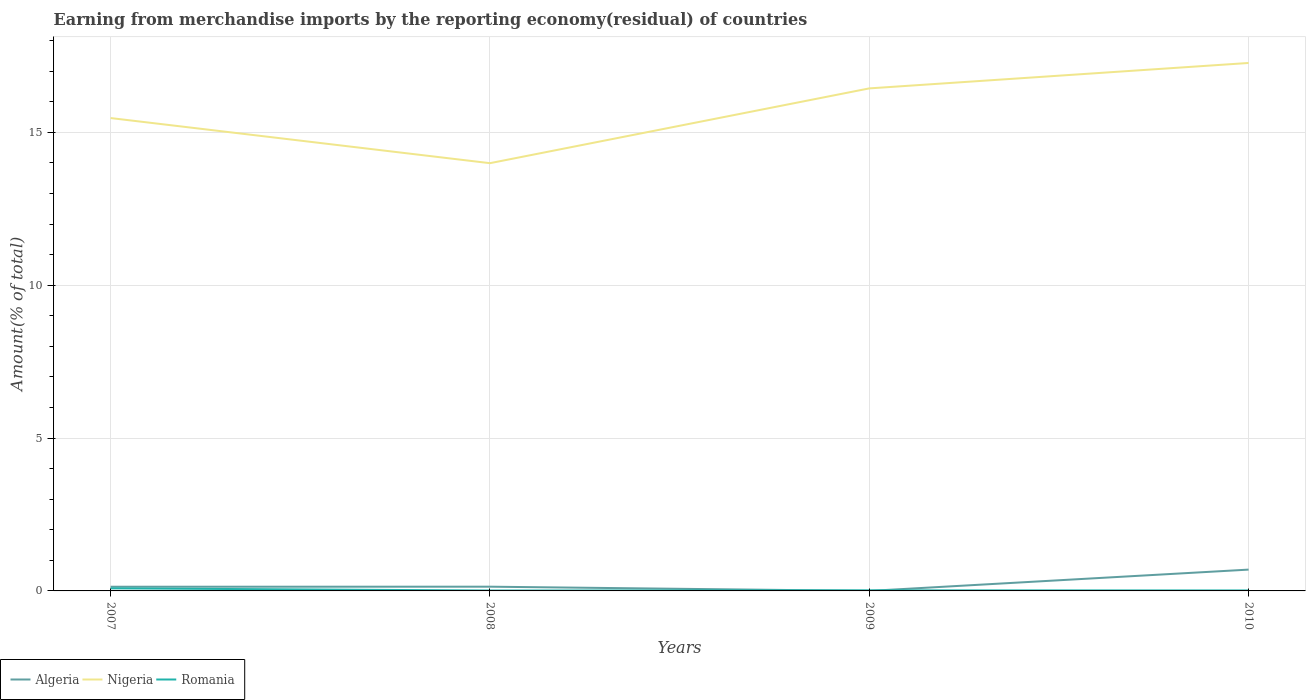How many different coloured lines are there?
Your answer should be very brief. 3. Does the line corresponding to Romania intersect with the line corresponding to Nigeria?
Provide a succinct answer. No. Is the number of lines equal to the number of legend labels?
Keep it short and to the point. Yes. Across all years, what is the maximum percentage of amount earned from merchandise imports in Nigeria?
Keep it short and to the point. 13.99. In which year was the percentage of amount earned from merchandise imports in Nigeria maximum?
Offer a very short reply. 2008. What is the total percentage of amount earned from merchandise imports in Algeria in the graph?
Your response must be concise. -0.7. What is the difference between the highest and the second highest percentage of amount earned from merchandise imports in Nigeria?
Your answer should be compact. 3.28. Does the graph contain any zero values?
Provide a succinct answer. No. Does the graph contain grids?
Keep it short and to the point. Yes. How many legend labels are there?
Give a very brief answer. 3. What is the title of the graph?
Make the answer very short. Earning from merchandise imports by the reporting economy(residual) of countries. What is the label or title of the Y-axis?
Ensure brevity in your answer.  Amount(% of total). What is the Amount(% of total) of Algeria in 2007?
Give a very brief answer. 0.14. What is the Amount(% of total) of Nigeria in 2007?
Offer a terse response. 15.47. What is the Amount(% of total) in Romania in 2007?
Ensure brevity in your answer.  0.08. What is the Amount(% of total) in Algeria in 2008?
Your answer should be compact. 0.14. What is the Amount(% of total) of Nigeria in 2008?
Ensure brevity in your answer.  13.99. What is the Amount(% of total) of Romania in 2008?
Your answer should be compact. 0.01. What is the Amount(% of total) in Algeria in 2009?
Provide a succinct answer. 0. What is the Amount(% of total) of Nigeria in 2009?
Provide a succinct answer. 16.44. What is the Amount(% of total) of Romania in 2009?
Ensure brevity in your answer.  0.02. What is the Amount(% of total) in Algeria in 2010?
Your answer should be compact. 0.7. What is the Amount(% of total) of Nigeria in 2010?
Give a very brief answer. 17.27. What is the Amount(% of total) of Romania in 2010?
Your answer should be compact. 0.02. Across all years, what is the maximum Amount(% of total) in Algeria?
Your answer should be compact. 0.7. Across all years, what is the maximum Amount(% of total) in Nigeria?
Give a very brief answer. 17.27. Across all years, what is the maximum Amount(% of total) of Romania?
Offer a very short reply. 0.08. Across all years, what is the minimum Amount(% of total) in Algeria?
Your answer should be compact. 0. Across all years, what is the minimum Amount(% of total) in Nigeria?
Provide a succinct answer. 13.99. Across all years, what is the minimum Amount(% of total) in Romania?
Offer a very short reply. 0.01. What is the total Amount(% of total) of Algeria in the graph?
Your response must be concise. 0.97. What is the total Amount(% of total) in Nigeria in the graph?
Give a very brief answer. 63.17. What is the total Amount(% of total) in Romania in the graph?
Offer a very short reply. 0.13. What is the difference between the Amount(% of total) in Algeria in 2007 and that in 2008?
Provide a succinct answer. -0. What is the difference between the Amount(% of total) in Nigeria in 2007 and that in 2008?
Keep it short and to the point. 1.48. What is the difference between the Amount(% of total) in Romania in 2007 and that in 2008?
Provide a succinct answer. 0.07. What is the difference between the Amount(% of total) in Algeria in 2007 and that in 2009?
Make the answer very short. 0.14. What is the difference between the Amount(% of total) of Nigeria in 2007 and that in 2009?
Keep it short and to the point. -0.97. What is the difference between the Amount(% of total) of Romania in 2007 and that in 2009?
Keep it short and to the point. 0.07. What is the difference between the Amount(% of total) in Algeria in 2007 and that in 2010?
Offer a terse response. -0.56. What is the difference between the Amount(% of total) in Nigeria in 2007 and that in 2010?
Give a very brief answer. -1.8. What is the difference between the Amount(% of total) in Romania in 2007 and that in 2010?
Keep it short and to the point. 0.07. What is the difference between the Amount(% of total) in Algeria in 2008 and that in 2009?
Offer a terse response. 0.14. What is the difference between the Amount(% of total) in Nigeria in 2008 and that in 2009?
Ensure brevity in your answer.  -2.45. What is the difference between the Amount(% of total) in Romania in 2008 and that in 2009?
Your response must be concise. -0.01. What is the difference between the Amount(% of total) in Algeria in 2008 and that in 2010?
Ensure brevity in your answer.  -0.56. What is the difference between the Amount(% of total) of Nigeria in 2008 and that in 2010?
Your answer should be very brief. -3.28. What is the difference between the Amount(% of total) in Romania in 2008 and that in 2010?
Your response must be concise. -0. What is the difference between the Amount(% of total) of Algeria in 2009 and that in 2010?
Your answer should be very brief. -0.7. What is the difference between the Amount(% of total) of Nigeria in 2009 and that in 2010?
Make the answer very short. -0.83. What is the difference between the Amount(% of total) in Romania in 2009 and that in 2010?
Your answer should be very brief. 0. What is the difference between the Amount(% of total) of Algeria in 2007 and the Amount(% of total) of Nigeria in 2008?
Make the answer very short. -13.86. What is the difference between the Amount(% of total) of Algeria in 2007 and the Amount(% of total) of Romania in 2008?
Your answer should be compact. 0.12. What is the difference between the Amount(% of total) of Nigeria in 2007 and the Amount(% of total) of Romania in 2008?
Keep it short and to the point. 15.46. What is the difference between the Amount(% of total) of Algeria in 2007 and the Amount(% of total) of Nigeria in 2009?
Offer a terse response. -16.3. What is the difference between the Amount(% of total) of Algeria in 2007 and the Amount(% of total) of Romania in 2009?
Make the answer very short. 0.12. What is the difference between the Amount(% of total) in Nigeria in 2007 and the Amount(% of total) in Romania in 2009?
Make the answer very short. 15.45. What is the difference between the Amount(% of total) in Algeria in 2007 and the Amount(% of total) in Nigeria in 2010?
Make the answer very short. -17.13. What is the difference between the Amount(% of total) of Algeria in 2007 and the Amount(% of total) of Romania in 2010?
Your answer should be compact. 0.12. What is the difference between the Amount(% of total) of Nigeria in 2007 and the Amount(% of total) of Romania in 2010?
Make the answer very short. 15.45. What is the difference between the Amount(% of total) of Algeria in 2008 and the Amount(% of total) of Nigeria in 2009?
Offer a terse response. -16.3. What is the difference between the Amount(% of total) of Algeria in 2008 and the Amount(% of total) of Romania in 2009?
Offer a terse response. 0.12. What is the difference between the Amount(% of total) in Nigeria in 2008 and the Amount(% of total) in Romania in 2009?
Give a very brief answer. 13.97. What is the difference between the Amount(% of total) in Algeria in 2008 and the Amount(% of total) in Nigeria in 2010?
Your response must be concise. -17.13. What is the difference between the Amount(% of total) in Algeria in 2008 and the Amount(% of total) in Romania in 2010?
Offer a terse response. 0.12. What is the difference between the Amount(% of total) of Nigeria in 2008 and the Amount(% of total) of Romania in 2010?
Your answer should be very brief. 13.98. What is the difference between the Amount(% of total) in Algeria in 2009 and the Amount(% of total) in Nigeria in 2010?
Ensure brevity in your answer.  -17.27. What is the difference between the Amount(% of total) in Algeria in 2009 and the Amount(% of total) in Romania in 2010?
Provide a short and direct response. -0.02. What is the difference between the Amount(% of total) of Nigeria in 2009 and the Amount(% of total) of Romania in 2010?
Ensure brevity in your answer.  16.42. What is the average Amount(% of total) in Algeria per year?
Provide a short and direct response. 0.24. What is the average Amount(% of total) of Nigeria per year?
Give a very brief answer. 15.79. What is the average Amount(% of total) of Romania per year?
Provide a short and direct response. 0.03. In the year 2007, what is the difference between the Amount(% of total) in Algeria and Amount(% of total) in Nigeria?
Offer a very short reply. -15.33. In the year 2007, what is the difference between the Amount(% of total) of Algeria and Amount(% of total) of Romania?
Provide a short and direct response. 0.05. In the year 2007, what is the difference between the Amount(% of total) of Nigeria and Amount(% of total) of Romania?
Your response must be concise. 15.38. In the year 2008, what is the difference between the Amount(% of total) of Algeria and Amount(% of total) of Nigeria?
Provide a succinct answer. -13.85. In the year 2008, what is the difference between the Amount(% of total) in Algeria and Amount(% of total) in Romania?
Your answer should be very brief. 0.13. In the year 2008, what is the difference between the Amount(% of total) in Nigeria and Amount(% of total) in Romania?
Your response must be concise. 13.98. In the year 2009, what is the difference between the Amount(% of total) in Algeria and Amount(% of total) in Nigeria?
Ensure brevity in your answer.  -16.44. In the year 2009, what is the difference between the Amount(% of total) in Algeria and Amount(% of total) in Romania?
Offer a terse response. -0.02. In the year 2009, what is the difference between the Amount(% of total) in Nigeria and Amount(% of total) in Romania?
Ensure brevity in your answer.  16.42. In the year 2010, what is the difference between the Amount(% of total) of Algeria and Amount(% of total) of Nigeria?
Give a very brief answer. -16.57. In the year 2010, what is the difference between the Amount(% of total) in Algeria and Amount(% of total) in Romania?
Your response must be concise. 0.68. In the year 2010, what is the difference between the Amount(% of total) in Nigeria and Amount(% of total) in Romania?
Ensure brevity in your answer.  17.26. What is the ratio of the Amount(% of total) of Algeria in 2007 to that in 2008?
Your answer should be compact. 0.99. What is the ratio of the Amount(% of total) in Nigeria in 2007 to that in 2008?
Your answer should be compact. 1.11. What is the ratio of the Amount(% of total) in Romania in 2007 to that in 2008?
Provide a succinct answer. 6.4. What is the ratio of the Amount(% of total) of Algeria in 2007 to that in 2009?
Make the answer very short. 1363.24. What is the ratio of the Amount(% of total) of Nigeria in 2007 to that in 2009?
Offer a very short reply. 0.94. What is the ratio of the Amount(% of total) in Romania in 2007 to that in 2009?
Give a very brief answer. 4.52. What is the ratio of the Amount(% of total) in Algeria in 2007 to that in 2010?
Your answer should be very brief. 0.2. What is the ratio of the Amount(% of total) in Nigeria in 2007 to that in 2010?
Provide a short and direct response. 0.9. What is the ratio of the Amount(% of total) in Romania in 2007 to that in 2010?
Provide a short and direct response. 5.59. What is the ratio of the Amount(% of total) in Algeria in 2008 to that in 2009?
Ensure brevity in your answer.  1381.85. What is the ratio of the Amount(% of total) of Nigeria in 2008 to that in 2009?
Offer a very short reply. 0.85. What is the ratio of the Amount(% of total) in Romania in 2008 to that in 2009?
Keep it short and to the point. 0.71. What is the ratio of the Amount(% of total) in Algeria in 2008 to that in 2010?
Make the answer very short. 0.2. What is the ratio of the Amount(% of total) in Nigeria in 2008 to that in 2010?
Provide a short and direct response. 0.81. What is the ratio of the Amount(% of total) in Romania in 2008 to that in 2010?
Your answer should be compact. 0.87. What is the ratio of the Amount(% of total) in Nigeria in 2009 to that in 2010?
Your answer should be very brief. 0.95. What is the ratio of the Amount(% of total) in Romania in 2009 to that in 2010?
Offer a terse response. 1.24. What is the difference between the highest and the second highest Amount(% of total) of Algeria?
Offer a very short reply. 0.56. What is the difference between the highest and the second highest Amount(% of total) of Nigeria?
Offer a terse response. 0.83. What is the difference between the highest and the second highest Amount(% of total) in Romania?
Give a very brief answer. 0.07. What is the difference between the highest and the lowest Amount(% of total) in Algeria?
Provide a succinct answer. 0.7. What is the difference between the highest and the lowest Amount(% of total) in Nigeria?
Offer a terse response. 3.28. What is the difference between the highest and the lowest Amount(% of total) in Romania?
Offer a very short reply. 0.07. 